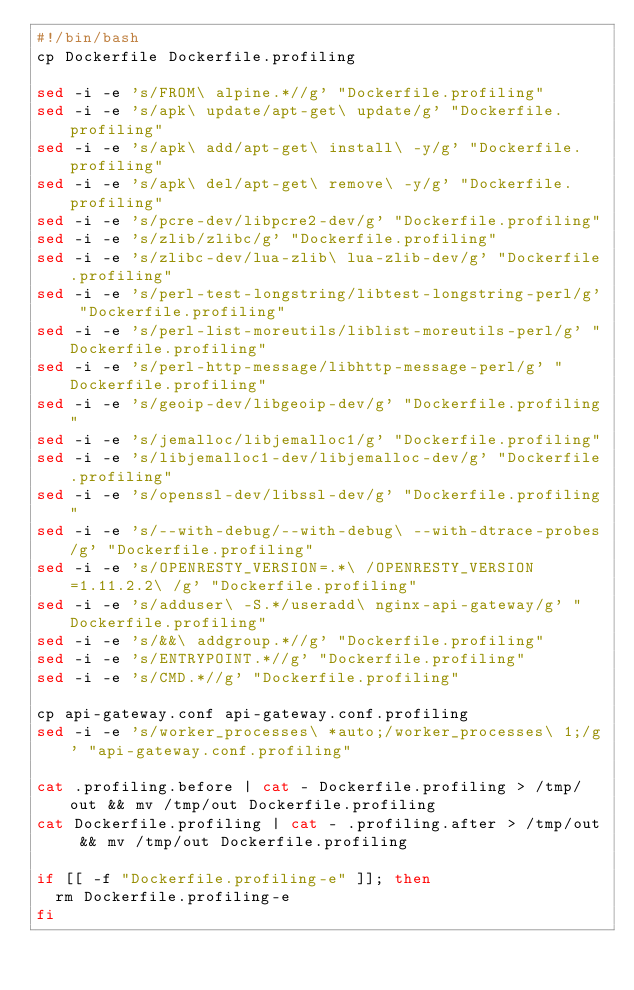<code> <loc_0><loc_0><loc_500><loc_500><_Bash_>#!/bin/bash
cp Dockerfile Dockerfile.profiling

sed -i -e 's/FROM\ alpine.*//g' "Dockerfile.profiling"
sed -i -e 's/apk\ update/apt-get\ update/g' "Dockerfile.profiling" 
sed -i -e 's/apk\ add/apt-get\ install\ -y/g' "Dockerfile.profiling" 
sed -i -e 's/apk\ del/apt-get\ remove\ -y/g' "Dockerfile.profiling"
sed -i -e 's/pcre-dev/libpcre2-dev/g' "Dockerfile.profiling"
sed -i -e 's/zlib/zlibc/g' "Dockerfile.profiling"
sed -i -e 's/zlibc-dev/lua-zlib\ lua-zlib-dev/g' "Dockerfile.profiling" 
sed -i -e 's/perl-test-longstring/libtest-longstring-perl/g' "Dockerfile.profiling"
sed -i -e 's/perl-list-moreutils/liblist-moreutils-perl/g' "Dockerfile.profiling" 
sed -i -e 's/perl-http-message/libhttp-message-perl/g' "Dockerfile.profiling" 
sed -i -e 's/geoip-dev/libgeoip-dev/g' "Dockerfile.profiling"
sed -i -e 's/jemalloc/libjemalloc1/g' "Dockerfile.profiling" 
sed -i -e 's/libjemalloc1-dev/libjemalloc-dev/g' "Dockerfile.profiling" 
sed -i -e 's/openssl-dev/libssl-dev/g' "Dockerfile.profiling" 
sed -i -e 's/--with-debug/--with-debug\ --with-dtrace-probes/g' "Dockerfile.profiling"
sed -i -e 's/OPENRESTY_VERSION=.*\ /OPENRESTY_VERSION=1.11.2.2\ /g' "Dockerfile.profiling"
sed -i -e 's/adduser\ -S.*/useradd\ nginx-api-gateway/g' "Dockerfile.profiling" 
sed -i -e 's/&&\ addgroup.*//g' "Dockerfile.profiling"
sed -i -e 's/ENTRYPOINT.*//g' "Dockerfile.profiling" 
sed -i -e 's/CMD.*//g' "Dockerfile.profiling"

cp api-gateway.conf api-gateway.conf.profiling
sed -i -e 's/worker_processes\ *auto;/worker_processes\ 1;/g' "api-gateway.conf.profiling"

cat .profiling.before | cat - Dockerfile.profiling > /tmp/out && mv /tmp/out Dockerfile.profiling
cat Dockerfile.profiling | cat - .profiling.after > /tmp/out && mv /tmp/out Dockerfile.profiling

if [[ -f "Dockerfile.profiling-e" ]]; then
	rm Dockerfile.profiling-e
fi
</code> 